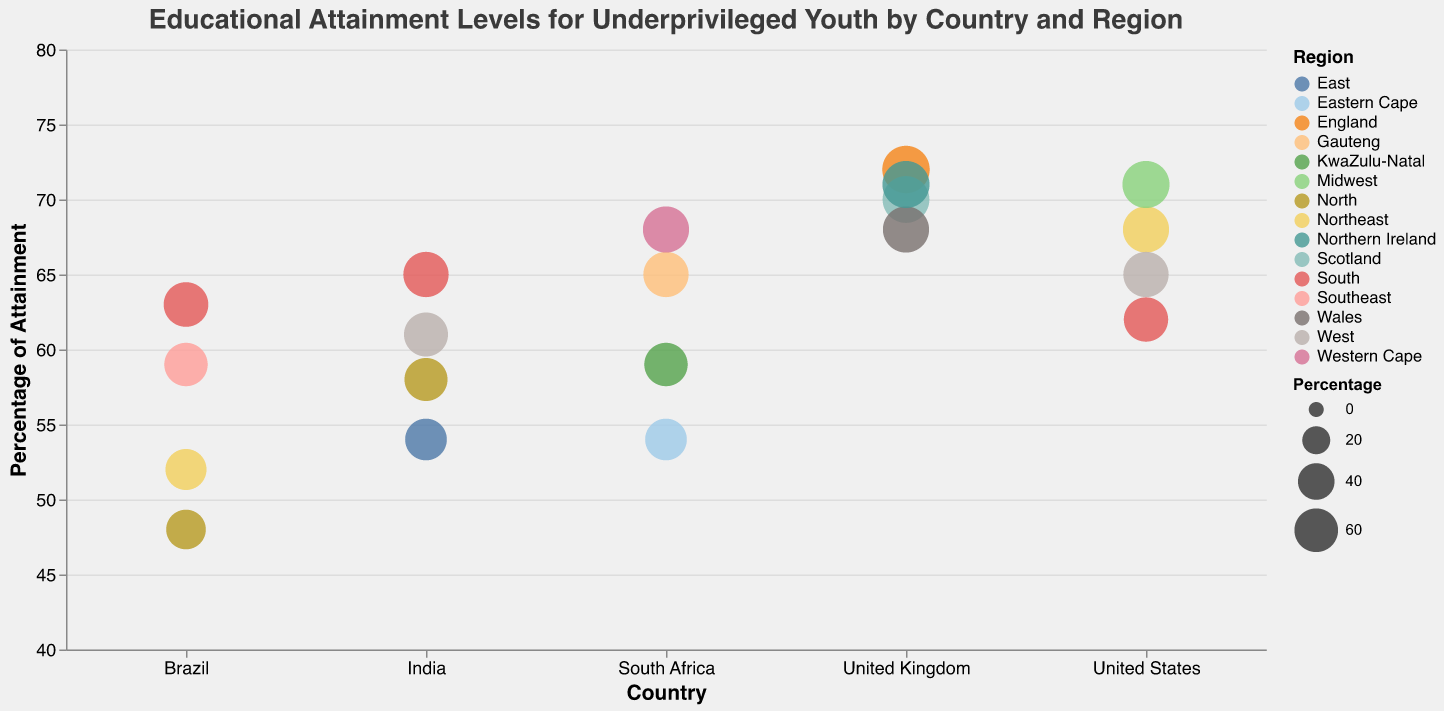What's the highest educational attainment percentage across all countries and regions? To determine the highest percentage, we need to look at all data points and identify the maximum value. The highest value in the dataset is 72% for England in the United Kingdom.
Answer: 72% Which region in the United States has the lowest percentage of high school diploma attainment? By examining the four regions in the United States, we see that the South has the lowest percentage at 62%.
Answer: South Between Scotland and Wales in the United Kingdom, which region has a higher percentage of educational attainment? Comparing the percentages, Scotland has 70% while Wales has 68%, so Scotland has a higher percentage.
Answer: Scotland What is the range of educational attainment percentages in Brazil? The range is calculated by subtracting the smallest percentage from the largest percentage in Brazil. The smallest is 48% (North) and the largest is 63% (South), so the range is 63% - 48% = 15%.
Answer: 15% What's the median percentage of educational attainment for the regions in India? The percentages for the regions in India are 58%, 65%, 54%, and 61%. Ordering them gives 54%, 58%, 61%, 65%. The median is the average of the two middle numbers: (58 + 61) / 2 = 59.5%.
Answer: 59.5% Which countries have at least one region with an educational attainment percentage above 70%? The countries with regions above 70% are the United States (Midwest), United Kingdom (England and Northern Ireland).
Answer: United States, United Kingdom How many regions are shown for Brazil? By counting the number of data points related to Brazil, we find there are four regions: Southeast, Northeast, South, and North.
Answer: 4 Which country has the most variation in educational attainment percentages across its regions? To determine variation, we can look at the range of percentages within each country. Brazil's range is 15% (48% to 63%), indicating the highest variation compared to the other countries.
Answer: Brazil What is the average educational attainment percentage for South African regions? The percentages are 65%, 68%, 59%, and 54%. Summing these gives (65 + 68 + 59 + 54) = 246, and dividing by 4 gives an average of 61.5%.
Answer: 61.5% In which region of South Africa is the attainment percentage lowest? Among the regions in South Africa, Eastern Cape has the lowest percentage at 54%.
Answer: Eastern Cape 